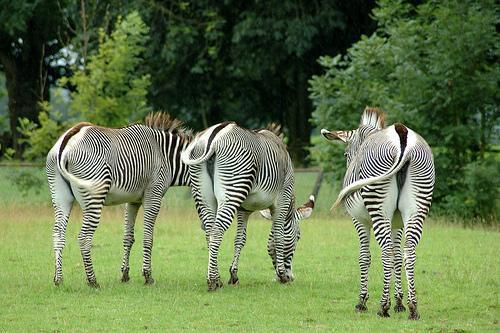How many zebras are there?
Give a very brief answer. 3. 